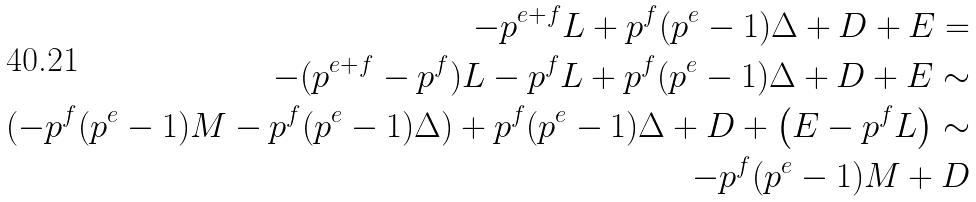Convert formula to latex. <formula><loc_0><loc_0><loc_500><loc_500>- p ^ { e + f } L + p ^ { f } ( p ^ { e } - 1 ) \Delta + D + E = \\ - ( p ^ { e + f } - p ^ { f } ) L - p ^ { f } L + p ^ { f } ( p ^ { e } - 1 ) \Delta + D + E \sim \\ ( - p ^ { f } ( p ^ { e } - 1 ) M - p ^ { f } ( p ^ { e } - 1 ) \Delta ) + p ^ { f } ( p ^ { e } - 1 ) \Delta + D + \left ( E - p ^ { f } L \right ) \sim \\ - p ^ { f } ( p ^ { e } - 1 ) M + D</formula> 